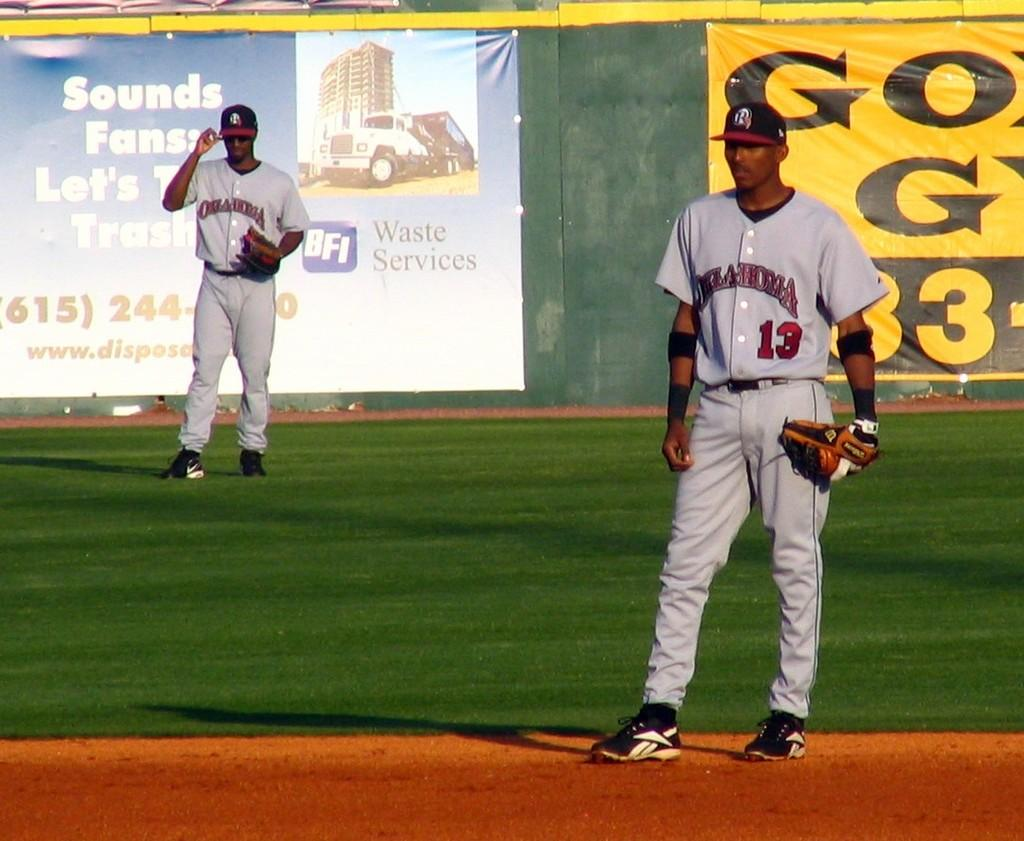Provide a one-sentence caption for the provided image. Two baseball players from the team Oklahoma on the field of play. 